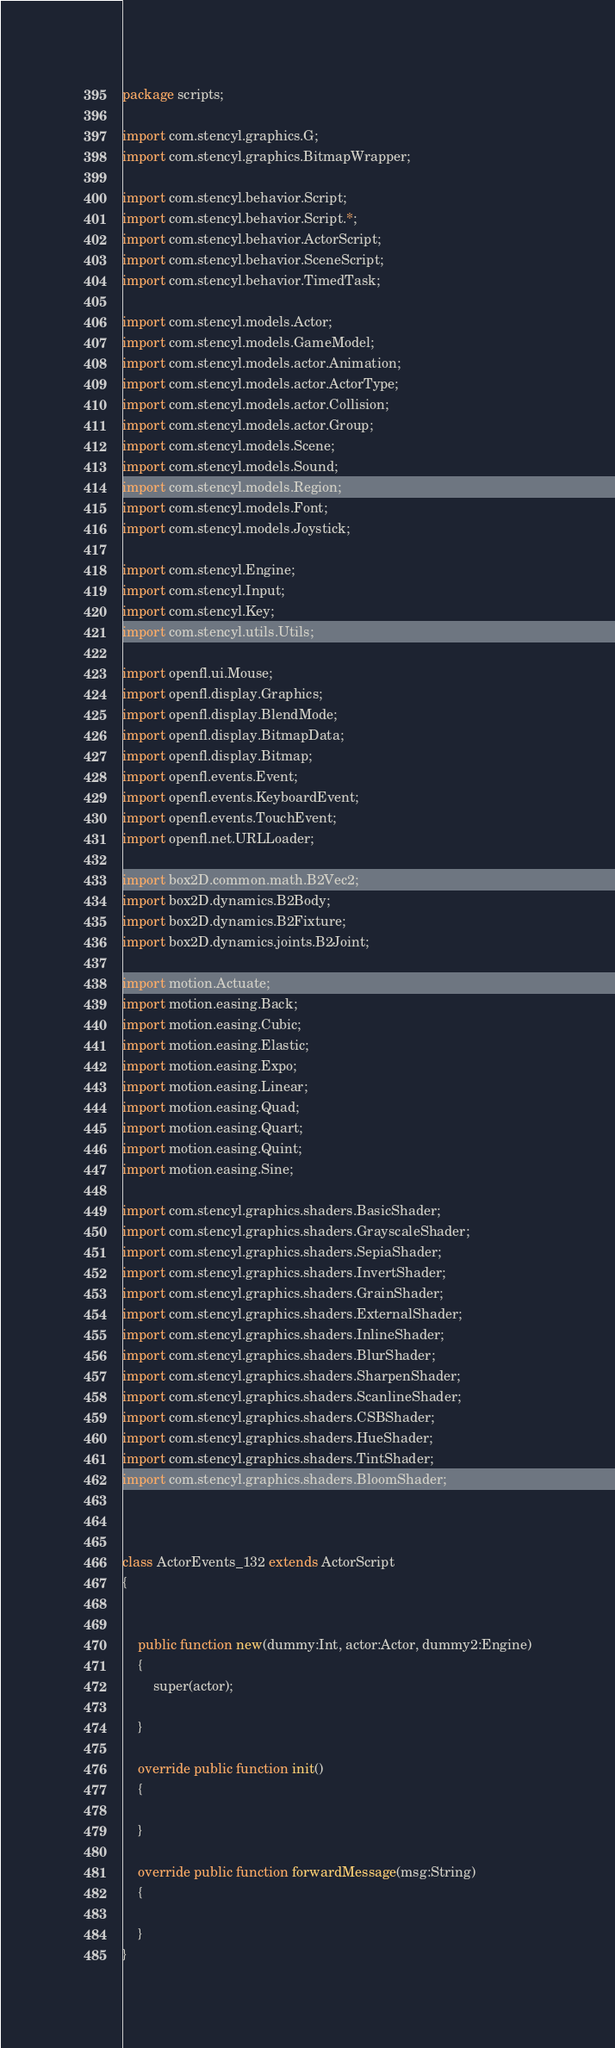Convert code to text. <code><loc_0><loc_0><loc_500><loc_500><_Haxe_>package scripts;

import com.stencyl.graphics.G;
import com.stencyl.graphics.BitmapWrapper;

import com.stencyl.behavior.Script;
import com.stencyl.behavior.Script.*;
import com.stencyl.behavior.ActorScript;
import com.stencyl.behavior.SceneScript;
import com.stencyl.behavior.TimedTask;

import com.stencyl.models.Actor;
import com.stencyl.models.GameModel;
import com.stencyl.models.actor.Animation;
import com.stencyl.models.actor.ActorType;
import com.stencyl.models.actor.Collision;
import com.stencyl.models.actor.Group;
import com.stencyl.models.Scene;
import com.stencyl.models.Sound;
import com.stencyl.models.Region;
import com.stencyl.models.Font;
import com.stencyl.models.Joystick;

import com.stencyl.Engine;
import com.stencyl.Input;
import com.stencyl.Key;
import com.stencyl.utils.Utils;

import openfl.ui.Mouse;
import openfl.display.Graphics;
import openfl.display.BlendMode;
import openfl.display.BitmapData;
import openfl.display.Bitmap;
import openfl.events.Event;
import openfl.events.KeyboardEvent;
import openfl.events.TouchEvent;
import openfl.net.URLLoader;

import box2D.common.math.B2Vec2;
import box2D.dynamics.B2Body;
import box2D.dynamics.B2Fixture;
import box2D.dynamics.joints.B2Joint;

import motion.Actuate;
import motion.easing.Back;
import motion.easing.Cubic;
import motion.easing.Elastic;
import motion.easing.Expo;
import motion.easing.Linear;
import motion.easing.Quad;
import motion.easing.Quart;
import motion.easing.Quint;
import motion.easing.Sine;

import com.stencyl.graphics.shaders.BasicShader;
import com.stencyl.graphics.shaders.GrayscaleShader;
import com.stencyl.graphics.shaders.SepiaShader;
import com.stencyl.graphics.shaders.InvertShader;
import com.stencyl.graphics.shaders.GrainShader;
import com.stencyl.graphics.shaders.ExternalShader;
import com.stencyl.graphics.shaders.InlineShader;
import com.stencyl.graphics.shaders.BlurShader;
import com.stencyl.graphics.shaders.SharpenShader;
import com.stencyl.graphics.shaders.ScanlineShader;
import com.stencyl.graphics.shaders.CSBShader;
import com.stencyl.graphics.shaders.HueShader;
import com.stencyl.graphics.shaders.TintShader;
import com.stencyl.graphics.shaders.BloomShader;



class ActorEvents_132 extends ActorScript
{
	
	
	public function new(dummy:Int, actor:Actor, dummy2:Engine)
	{
		super(actor);
		
	}
	
	override public function init()
	{
		
	}
	
	override public function forwardMessage(msg:String)
	{
		
	}
}</code> 